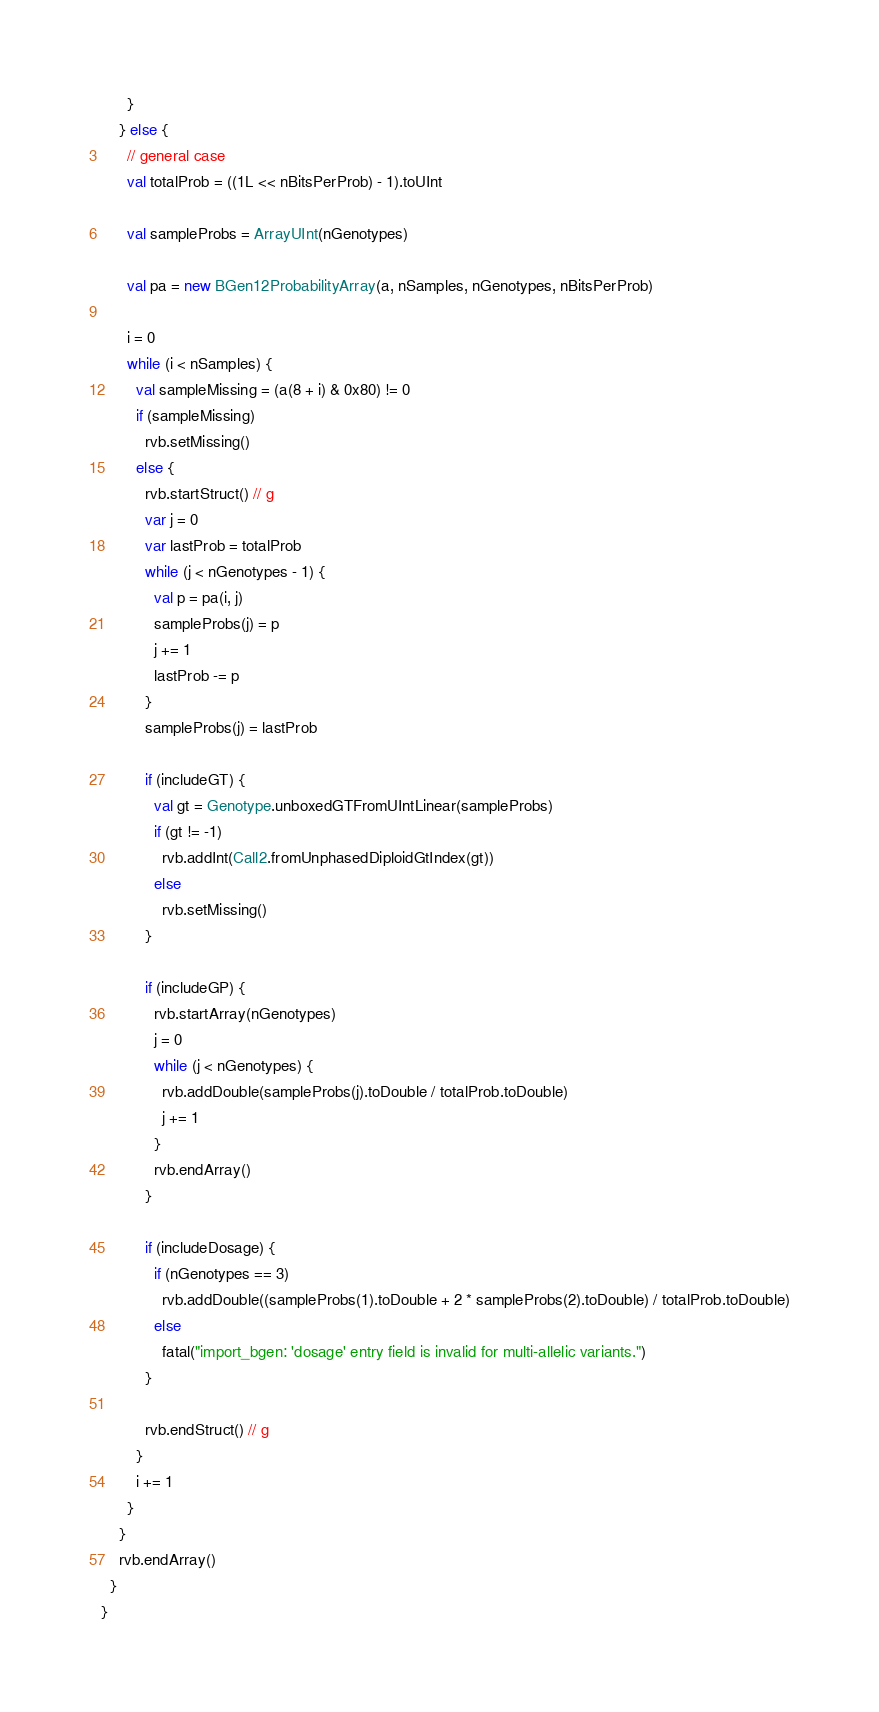Convert code to text. <code><loc_0><loc_0><loc_500><loc_500><_Scala_>      }
    } else {
      // general case
      val totalProb = ((1L << nBitsPerProb) - 1).toUInt

      val sampleProbs = ArrayUInt(nGenotypes)

      val pa = new BGen12ProbabilityArray(a, nSamples, nGenotypes, nBitsPerProb)

      i = 0
      while (i < nSamples) {
        val sampleMissing = (a(8 + i) & 0x80) != 0
        if (sampleMissing)
          rvb.setMissing()
        else {
          rvb.startStruct() // g
          var j = 0
          var lastProb = totalProb
          while (j < nGenotypes - 1) {
            val p = pa(i, j)
            sampleProbs(j) = p
            j += 1
            lastProb -= p
          }
          sampleProbs(j) = lastProb

          if (includeGT) {
            val gt = Genotype.unboxedGTFromUIntLinear(sampleProbs)
            if (gt != -1)
              rvb.addInt(Call2.fromUnphasedDiploidGtIndex(gt))
            else
              rvb.setMissing()
          }

          if (includeGP) {
            rvb.startArray(nGenotypes)
            j = 0
            while (j < nGenotypes) {
              rvb.addDouble(sampleProbs(j).toDouble / totalProb.toDouble)
              j += 1
            }
            rvb.endArray()
          }

          if (includeDosage) {
            if (nGenotypes == 3)
              rvb.addDouble((sampleProbs(1).toDouble + 2 * sampleProbs(2).toDouble) / totalProb.toDouble)
            else
              fatal("import_bgen: 'dosage' entry field is invalid for multi-allelic variants.")
          }

          rvb.endStruct() // g
        }
        i += 1
      }
    }
    rvb.endArray()
  }
}
</code> 